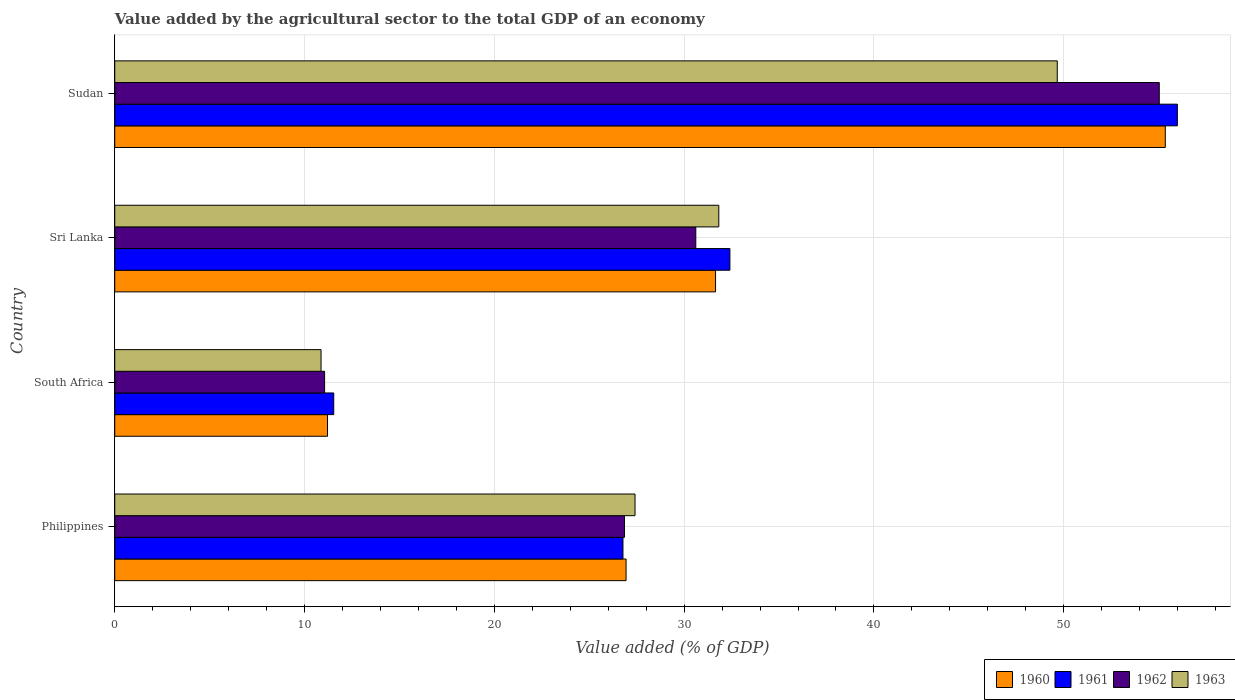How many different coloured bars are there?
Offer a terse response. 4. How many groups of bars are there?
Offer a terse response. 4. Are the number of bars per tick equal to the number of legend labels?
Give a very brief answer. Yes. How many bars are there on the 2nd tick from the bottom?
Your answer should be very brief. 4. What is the label of the 4th group of bars from the top?
Provide a short and direct response. Philippines. In how many cases, is the number of bars for a given country not equal to the number of legend labels?
Offer a terse response. 0. What is the value added by the agricultural sector to the total GDP in 1962 in Philippines?
Your answer should be compact. 26.86. Across all countries, what is the maximum value added by the agricultural sector to the total GDP in 1960?
Provide a short and direct response. 55.35. Across all countries, what is the minimum value added by the agricultural sector to the total GDP in 1960?
Offer a very short reply. 11.21. In which country was the value added by the agricultural sector to the total GDP in 1960 maximum?
Keep it short and to the point. Sudan. In which country was the value added by the agricultural sector to the total GDP in 1961 minimum?
Your response must be concise. South Africa. What is the total value added by the agricultural sector to the total GDP in 1962 in the graph?
Give a very brief answer. 123.56. What is the difference between the value added by the agricultural sector to the total GDP in 1961 in Philippines and that in Sudan?
Your answer should be very brief. -29.21. What is the difference between the value added by the agricultural sector to the total GDP in 1960 in Sri Lanka and the value added by the agricultural sector to the total GDP in 1961 in South Africa?
Provide a short and direct response. 20.12. What is the average value added by the agricultural sector to the total GDP in 1960 per country?
Keep it short and to the point. 31.29. What is the difference between the value added by the agricultural sector to the total GDP in 1962 and value added by the agricultural sector to the total GDP in 1961 in Sudan?
Your answer should be very brief. -0.95. In how many countries, is the value added by the agricultural sector to the total GDP in 1961 greater than 20 %?
Provide a short and direct response. 3. What is the ratio of the value added by the agricultural sector to the total GDP in 1963 in Philippines to that in Sudan?
Offer a very short reply. 0.55. Is the value added by the agricultural sector to the total GDP in 1960 in Philippines less than that in Sudan?
Make the answer very short. Yes. Is the difference between the value added by the agricultural sector to the total GDP in 1962 in South Africa and Sudan greater than the difference between the value added by the agricultural sector to the total GDP in 1961 in South Africa and Sudan?
Give a very brief answer. Yes. What is the difference between the highest and the second highest value added by the agricultural sector to the total GDP in 1960?
Give a very brief answer. 23.7. What is the difference between the highest and the lowest value added by the agricultural sector to the total GDP in 1961?
Your answer should be very brief. 44.45. Is the sum of the value added by the agricultural sector to the total GDP in 1963 in Philippines and Sri Lanka greater than the maximum value added by the agricultural sector to the total GDP in 1962 across all countries?
Provide a succinct answer. Yes. What does the 2nd bar from the top in South Africa represents?
Provide a short and direct response. 1962. What does the 4th bar from the bottom in Sri Lanka represents?
Provide a succinct answer. 1963. What is the difference between two consecutive major ticks on the X-axis?
Your answer should be compact. 10. Are the values on the major ticks of X-axis written in scientific E-notation?
Give a very brief answer. No. Does the graph contain grids?
Give a very brief answer. Yes. Where does the legend appear in the graph?
Your response must be concise. Bottom right. How are the legend labels stacked?
Make the answer very short. Horizontal. What is the title of the graph?
Make the answer very short. Value added by the agricultural sector to the total GDP of an economy. Does "1972" appear as one of the legend labels in the graph?
Make the answer very short. No. What is the label or title of the X-axis?
Your response must be concise. Value added (% of GDP). What is the label or title of the Y-axis?
Your response must be concise. Country. What is the Value added (% of GDP) in 1960 in Philippines?
Provide a succinct answer. 26.94. What is the Value added (% of GDP) in 1961 in Philippines?
Offer a very short reply. 26.78. What is the Value added (% of GDP) of 1962 in Philippines?
Offer a very short reply. 26.86. What is the Value added (% of GDP) of 1963 in Philippines?
Your response must be concise. 27.41. What is the Value added (% of GDP) of 1960 in South Africa?
Provide a short and direct response. 11.21. What is the Value added (% of GDP) in 1961 in South Africa?
Provide a short and direct response. 11.54. What is the Value added (% of GDP) of 1962 in South Africa?
Your response must be concise. 11.06. What is the Value added (% of GDP) in 1963 in South Africa?
Offer a very short reply. 10.87. What is the Value added (% of GDP) in 1960 in Sri Lanka?
Give a very brief answer. 31.66. What is the Value added (% of GDP) in 1961 in Sri Lanka?
Offer a very short reply. 32.41. What is the Value added (% of GDP) of 1962 in Sri Lanka?
Your answer should be compact. 30.61. What is the Value added (% of GDP) of 1963 in Sri Lanka?
Give a very brief answer. 31.83. What is the Value added (% of GDP) of 1960 in Sudan?
Provide a short and direct response. 55.35. What is the Value added (% of GDP) in 1961 in Sudan?
Your answer should be compact. 55.99. What is the Value added (% of GDP) in 1962 in Sudan?
Make the answer very short. 55.03. What is the Value added (% of GDP) in 1963 in Sudan?
Give a very brief answer. 49.66. Across all countries, what is the maximum Value added (% of GDP) in 1960?
Your answer should be very brief. 55.35. Across all countries, what is the maximum Value added (% of GDP) of 1961?
Provide a succinct answer. 55.99. Across all countries, what is the maximum Value added (% of GDP) in 1962?
Your answer should be compact. 55.03. Across all countries, what is the maximum Value added (% of GDP) in 1963?
Give a very brief answer. 49.66. Across all countries, what is the minimum Value added (% of GDP) of 1960?
Provide a short and direct response. 11.21. Across all countries, what is the minimum Value added (% of GDP) in 1961?
Provide a short and direct response. 11.54. Across all countries, what is the minimum Value added (% of GDP) of 1962?
Offer a very short reply. 11.06. Across all countries, what is the minimum Value added (% of GDP) of 1963?
Offer a very short reply. 10.87. What is the total Value added (% of GDP) of 1960 in the graph?
Offer a terse response. 125.16. What is the total Value added (% of GDP) in 1961 in the graph?
Provide a short and direct response. 126.71. What is the total Value added (% of GDP) in 1962 in the graph?
Your answer should be very brief. 123.56. What is the total Value added (% of GDP) of 1963 in the graph?
Offer a terse response. 119.77. What is the difference between the Value added (% of GDP) in 1960 in Philippines and that in South Africa?
Your answer should be very brief. 15.73. What is the difference between the Value added (% of GDP) in 1961 in Philippines and that in South Africa?
Provide a succinct answer. 15.24. What is the difference between the Value added (% of GDP) in 1962 in Philippines and that in South Africa?
Offer a very short reply. 15.8. What is the difference between the Value added (% of GDP) of 1963 in Philippines and that in South Africa?
Your answer should be compact. 16.54. What is the difference between the Value added (% of GDP) of 1960 in Philippines and that in Sri Lanka?
Your response must be concise. -4.72. What is the difference between the Value added (% of GDP) of 1961 in Philippines and that in Sri Lanka?
Provide a succinct answer. -5.63. What is the difference between the Value added (% of GDP) of 1962 in Philippines and that in Sri Lanka?
Offer a very short reply. -3.76. What is the difference between the Value added (% of GDP) in 1963 in Philippines and that in Sri Lanka?
Keep it short and to the point. -4.41. What is the difference between the Value added (% of GDP) of 1960 in Philippines and that in Sudan?
Provide a succinct answer. -28.41. What is the difference between the Value added (% of GDP) of 1961 in Philippines and that in Sudan?
Ensure brevity in your answer.  -29.21. What is the difference between the Value added (% of GDP) in 1962 in Philippines and that in Sudan?
Keep it short and to the point. -28.18. What is the difference between the Value added (% of GDP) of 1963 in Philippines and that in Sudan?
Ensure brevity in your answer.  -22.25. What is the difference between the Value added (% of GDP) in 1960 in South Africa and that in Sri Lanka?
Make the answer very short. -20.45. What is the difference between the Value added (% of GDP) in 1961 in South Africa and that in Sri Lanka?
Make the answer very short. -20.87. What is the difference between the Value added (% of GDP) in 1962 in South Africa and that in Sri Lanka?
Provide a succinct answer. -19.56. What is the difference between the Value added (% of GDP) of 1963 in South Africa and that in Sri Lanka?
Keep it short and to the point. -20.96. What is the difference between the Value added (% of GDP) of 1960 in South Africa and that in Sudan?
Your answer should be compact. -44.14. What is the difference between the Value added (% of GDP) in 1961 in South Africa and that in Sudan?
Provide a short and direct response. -44.45. What is the difference between the Value added (% of GDP) in 1962 in South Africa and that in Sudan?
Your response must be concise. -43.98. What is the difference between the Value added (% of GDP) of 1963 in South Africa and that in Sudan?
Your response must be concise. -38.79. What is the difference between the Value added (% of GDP) in 1960 in Sri Lanka and that in Sudan?
Ensure brevity in your answer.  -23.7. What is the difference between the Value added (% of GDP) in 1961 in Sri Lanka and that in Sudan?
Ensure brevity in your answer.  -23.58. What is the difference between the Value added (% of GDP) in 1962 in Sri Lanka and that in Sudan?
Your response must be concise. -24.42. What is the difference between the Value added (% of GDP) of 1963 in Sri Lanka and that in Sudan?
Make the answer very short. -17.83. What is the difference between the Value added (% of GDP) of 1960 in Philippines and the Value added (% of GDP) of 1961 in South Africa?
Provide a succinct answer. 15.4. What is the difference between the Value added (% of GDP) in 1960 in Philippines and the Value added (% of GDP) in 1962 in South Africa?
Your response must be concise. 15.88. What is the difference between the Value added (% of GDP) of 1960 in Philippines and the Value added (% of GDP) of 1963 in South Africa?
Offer a terse response. 16.07. What is the difference between the Value added (% of GDP) in 1961 in Philippines and the Value added (% of GDP) in 1962 in South Africa?
Offer a very short reply. 15.72. What is the difference between the Value added (% of GDP) of 1961 in Philippines and the Value added (% of GDP) of 1963 in South Africa?
Provide a succinct answer. 15.91. What is the difference between the Value added (% of GDP) of 1962 in Philippines and the Value added (% of GDP) of 1963 in South Africa?
Provide a short and direct response. 15.99. What is the difference between the Value added (% of GDP) in 1960 in Philippines and the Value added (% of GDP) in 1961 in Sri Lanka?
Provide a succinct answer. -5.47. What is the difference between the Value added (% of GDP) in 1960 in Philippines and the Value added (% of GDP) in 1962 in Sri Lanka?
Offer a terse response. -3.67. What is the difference between the Value added (% of GDP) of 1960 in Philippines and the Value added (% of GDP) of 1963 in Sri Lanka?
Provide a short and direct response. -4.89. What is the difference between the Value added (% of GDP) of 1961 in Philippines and the Value added (% of GDP) of 1962 in Sri Lanka?
Ensure brevity in your answer.  -3.84. What is the difference between the Value added (% of GDP) in 1961 in Philippines and the Value added (% of GDP) in 1963 in Sri Lanka?
Give a very brief answer. -5.05. What is the difference between the Value added (% of GDP) of 1962 in Philippines and the Value added (% of GDP) of 1963 in Sri Lanka?
Your answer should be compact. -4.97. What is the difference between the Value added (% of GDP) in 1960 in Philippines and the Value added (% of GDP) in 1961 in Sudan?
Provide a succinct answer. -29.05. What is the difference between the Value added (% of GDP) of 1960 in Philippines and the Value added (% of GDP) of 1962 in Sudan?
Your answer should be very brief. -28.09. What is the difference between the Value added (% of GDP) of 1960 in Philippines and the Value added (% of GDP) of 1963 in Sudan?
Make the answer very short. -22.72. What is the difference between the Value added (% of GDP) in 1961 in Philippines and the Value added (% of GDP) in 1962 in Sudan?
Offer a very short reply. -28.26. What is the difference between the Value added (% of GDP) of 1961 in Philippines and the Value added (% of GDP) of 1963 in Sudan?
Keep it short and to the point. -22.88. What is the difference between the Value added (% of GDP) in 1962 in Philippines and the Value added (% of GDP) in 1963 in Sudan?
Give a very brief answer. -22.8. What is the difference between the Value added (% of GDP) of 1960 in South Africa and the Value added (% of GDP) of 1961 in Sri Lanka?
Your answer should be compact. -21.2. What is the difference between the Value added (% of GDP) of 1960 in South Africa and the Value added (% of GDP) of 1962 in Sri Lanka?
Provide a short and direct response. -19.4. What is the difference between the Value added (% of GDP) of 1960 in South Africa and the Value added (% of GDP) of 1963 in Sri Lanka?
Ensure brevity in your answer.  -20.62. What is the difference between the Value added (% of GDP) in 1961 in South Africa and the Value added (% of GDP) in 1962 in Sri Lanka?
Give a very brief answer. -19.08. What is the difference between the Value added (% of GDP) in 1961 in South Africa and the Value added (% of GDP) in 1963 in Sri Lanka?
Your answer should be very brief. -20.29. What is the difference between the Value added (% of GDP) of 1962 in South Africa and the Value added (% of GDP) of 1963 in Sri Lanka?
Your response must be concise. -20.77. What is the difference between the Value added (% of GDP) in 1960 in South Africa and the Value added (% of GDP) in 1961 in Sudan?
Your answer should be very brief. -44.78. What is the difference between the Value added (% of GDP) of 1960 in South Africa and the Value added (% of GDP) of 1962 in Sudan?
Your answer should be compact. -43.82. What is the difference between the Value added (% of GDP) of 1960 in South Africa and the Value added (% of GDP) of 1963 in Sudan?
Offer a terse response. -38.45. What is the difference between the Value added (% of GDP) of 1961 in South Africa and the Value added (% of GDP) of 1962 in Sudan?
Ensure brevity in your answer.  -43.5. What is the difference between the Value added (% of GDP) in 1961 in South Africa and the Value added (% of GDP) in 1963 in Sudan?
Provide a short and direct response. -38.12. What is the difference between the Value added (% of GDP) of 1962 in South Africa and the Value added (% of GDP) of 1963 in Sudan?
Provide a succinct answer. -38.6. What is the difference between the Value added (% of GDP) of 1960 in Sri Lanka and the Value added (% of GDP) of 1961 in Sudan?
Provide a short and direct response. -24.33. What is the difference between the Value added (% of GDP) in 1960 in Sri Lanka and the Value added (% of GDP) in 1962 in Sudan?
Your answer should be compact. -23.38. What is the difference between the Value added (% of GDP) of 1960 in Sri Lanka and the Value added (% of GDP) of 1963 in Sudan?
Keep it short and to the point. -18. What is the difference between the Value added (% of GDP) of 1961 in Sri Lanka and the Value added (% of GDP) of 1962 in Sudan?
Provide a short and direct response. -22.62. What is the difference between the Value added (% of GDP) of 1961 in Sri Lanka and the Value added (% of GDP) of 1963 in Sudan?
Make the answer very short. -17.25. What is the difference between the Value added (% of GDP) in 1962 in Sri Lanka and the Value added (% of GDP) in 1963 in Sudan?
Make the answer very short. -19.04. What is the average Value added (% of GDP) in 1960 per country?
Provide a short and direct response. 31.29. What is the average Value added (% of GDP) in 1961 per country?
Your answer should be compact. 31.68. What is the average Value added (% of GDP) of 1962 per country?
Give a very brief answer. 30.89. What is the average Value added (% of GDP) in 1963 per country?
Your response must be concise. 29.94. What is the difference between the Value added (% of GDP) in 1960 and Value added (% of GDP) in 1961 in Philippines?
Your response must be concise. 0.16. What is the difference between the Value added (% of GDP) in 1960 and Value added (% of GDP) in 1962 in Philippines?
Make the answer very short. 0.08. What is the difference between the Value added (% of GDP) of 1960 and Value added (% of GDP) of 1963 in Philippines?
Ensure brevity in your answer.  -0.47. What is the difference between the Value added (% of GDP) in 1961 and Value added (% of GDP) in 1962 in Philippines?
Give a very brief answer. -0.08. What is the difference between the Value added (% of GDP) in 1961 and Value added (% of GDP) in 1963 in Philippines?
Your answer should be compact. -0.64. What is the difference between the Value added (% of GDP) in 1962 and Value added (% of GDP) in 1963 in Philippines?
Give a very brief answer. -0.55. What is the difference between the Value added (% of GDP) of 1960 and Value added (% of GDP) of 1961 in South Africa?
Offer a very short reply. -0.33. What is the difference between the Value added (% of GDP) in 1960 and Value added (% of GDP) in 1962 in South Africa?
Make the answer very short. 0.15. What is the difference between the Value added (% of GDP) in 1960 and Value added (% of GDP) in 1963 in South Africa?
Offer a terse response. 0.34. What is the difference between the Value added (% of GDP) of 1961 and Value added (% of GDP) of 1962 in South Africa?
Ensure brevity in your answer.  0.48. What is the difference between the Value added (% of GDP) of 1961 and Value added (% of GDP) of 1963 in South Africa?
Your answer should be very brief. 0.67. What is the difference between the Value added (% of GDP) in 1962 and Value added (% of GDP) in 1963 in South Africa?
Make the answer very short. 0.19. What is the difference between the Value added (% of GDP) in 1960 and Value added (% of GDP) in 1961 in Sri Lanka?
Ensure brevity in your answer.  -0.76. What is the difference between the Value added (% of GDP) in 1960 and Value added (% of GDP) in 1962 in Sri Lanka?
Provide a succinct answer. 1.04. What is the difference between the Value added (% of GDP) in 1960 and Value added (% of GDP) in 1963 in Sri Lanka?
Provide a short and direct response. -0.17. What is the difference between the Value added (% of GDP) of 1961 and Value added (% of GDP) of 1962 in Sri Lanka?
Offer a terse response. 1.8. What is the difference between the Value added (% of GDP) in 1961 and Value added (% of GDP) in 1963 in Sri Lanka?
Your answer should be compact. 0.59. What is the difference between the Value added (% of GDP) in 1962 and Value added (% of GDP) in 1963 in Sri Lanka?
Offer a very short reply. -1.21. What is the difference between the Value added (% of GDP) in 1960 and Value added (% of GDP) in 1961 in Sudan?
Keep it short and to the point. -0.64. What is the difference between the Value added (% of GDP) in 1960 and Value added (% of GDP) in 1962 in Sudan?
Provide a short and direct response. 0.32. What is the difference between the Value added (% of GDP) in 1960 and Value added (% of GDP) in 1963 in Sudan?
Your response must be concise. 5.69. What is the difference between the Value added (% of GDP) of 1961 and Value added (% of GDP) of 1962 in Sudan?
Offer a terse response. 0.95. What is the difference between the Value added (% of GDP) in 1961 and Value added (% of GDP) in 1963 in Sudan?
Ensure brevity in your answer.  6.33. What is the difference between the Value added (% of GDP) in 1962 and Value added (% of GDP) in 1963 in Sudan?
Keep it short and to the point. 5.37. What is the ratio of the Value added (% of GDP) in 1960 in Philippines to that in South Africa?
Give a very brief answer. 2.4. What is the ratio of the Value added (% of GDP) in 1961 in Philippines to that in South Africa?
Provide a short and direct response. 2.32. What is the ratio of the Value added (% of GDP) in 1962 in Philippines to that in South Africa?
Offer a very short reply. 2.43. What is the ratio of the Value added (% of GDP) of 1963 in Philippines to that in South Africa?
Offer a terse response. 2.52. What is the ratio of the Value added (% of GDP) of 1960 in Philippines to that in Sri Lanka?
Provide a short and direct response. 0.85. What is the ratio of the Value added (% of GDP) in 1961 in Philippines to that in Sri Lanka?
Provide a succinct answer. 0.83. What is the ratio of the Value added (% of GDP) of 1962 in Philippines to that in Sri Lanka?
Your answer should be compact. 0.88. What is the ratio of the Value added (% of GDP) in 1963 in Philippines to that in Sri Lanka?
Make the answer very short. 0.86. What is the ratio of the Value added (% of GDP) in 1960 in Philippines to that in Sudan?
Your answer should be very brief. 0.49. What is the ratio of the Value added (% of GDP) of 1961 in Philippines to that in Sudan?
Your response must be concise. 0.48. What is the ratio of the Value added (% of GDP) of 1962 in Philippines to that in Sudan?
Provide a short and direct response. 0.49. What is the ratio of the Value added (% of GDP) in 1963 in Philippines to that in Sudan?
Offer a very short reply. 0.55. What is the ratio of the Value added (% of GDP) of 1960 in South Africa to that in Sri Lanka?
Keep it short and to the point. 0.35. What is the ratio of the Value added (% of GDP) of 1961 in South Africa to that in Sri Lanka?
Your response must be concise. 0.36. What is the ratio of the Value added (% of GDP) of 1962 in South Africa to that in Sri Lanka?
Your answer should be very brief. 0.36. What is the ratio of the Value added (% of GDP) in 1963 in South Africa to that in Sri Lanka?
Give a very brief answer. 0.34. What is the ratio of the Value added (% of GDP) of 1960 in South Africa to that in Sudan?
Offer a terse response. 0.2. What is the ratio of the Value added (% of GDP) of 1961 in South Africa to that in Sudan?
Ensure brevity in your answer.  0.21. What is the ratio of the Value added (% of GDP) of 1962 in South Africa to that in Sudan?
Provide a short and direct response. 0.2. What is the ratio of the Value added (% of GDP) of 1963 in South Africa to that in Sudan?
Offer a very short reply. 0.22. What is the ratio of the Value added (% of GDP) in 1960 in Sri Lanka to that in Sudan?
Your answer should be compact. 0.57. What is the ratio of the Value added (% of GDP) in 1961 in Sri Lanka to that in Sudan?
Make the answer very short. 0.58. What is the ratio of the Value added (% of GDP) in 1962 in Sri Lanka to that in Sudan?
Your answer should be compact. 0.56. What is the ratio of the Value added (% of GDP) of 1963 in Sri Lanka to that in Sudan?
Offer a very short reply. 0.64. What is the difference between the highest and the second highest Value added (% of GDP) in 1960?
Give a very brief answer. 23.7. What is the difference between the highest and the second highest Value added (% of GDP) of 1961?
Your response must be concise. 23.58. What is the difference between the highest and the second highest Value added (% of GDP) of 1962?
Provide a succinct answer. 24.42. What is the difference between the highest and the second highest Value added (% of GDP) in 1963?
Your answer should be very brief. 17.83. What is the difference between the highest and the lowest Value added (% of GDP) of 1960?
Your answer should be compact. 44.14. What is the difference between the highest and the lowest Value added (% of GDP) of 1961?
Your response must be concise. 44.45. What is the difference between the highest and the lowest Value added (% of GDP) of 1962?
Offer a very short reply. 43.98. What is the difference between the highest and the lowest Value added (% of GDP) of 1963?
Ensure brevity in your answer.  38.79. 